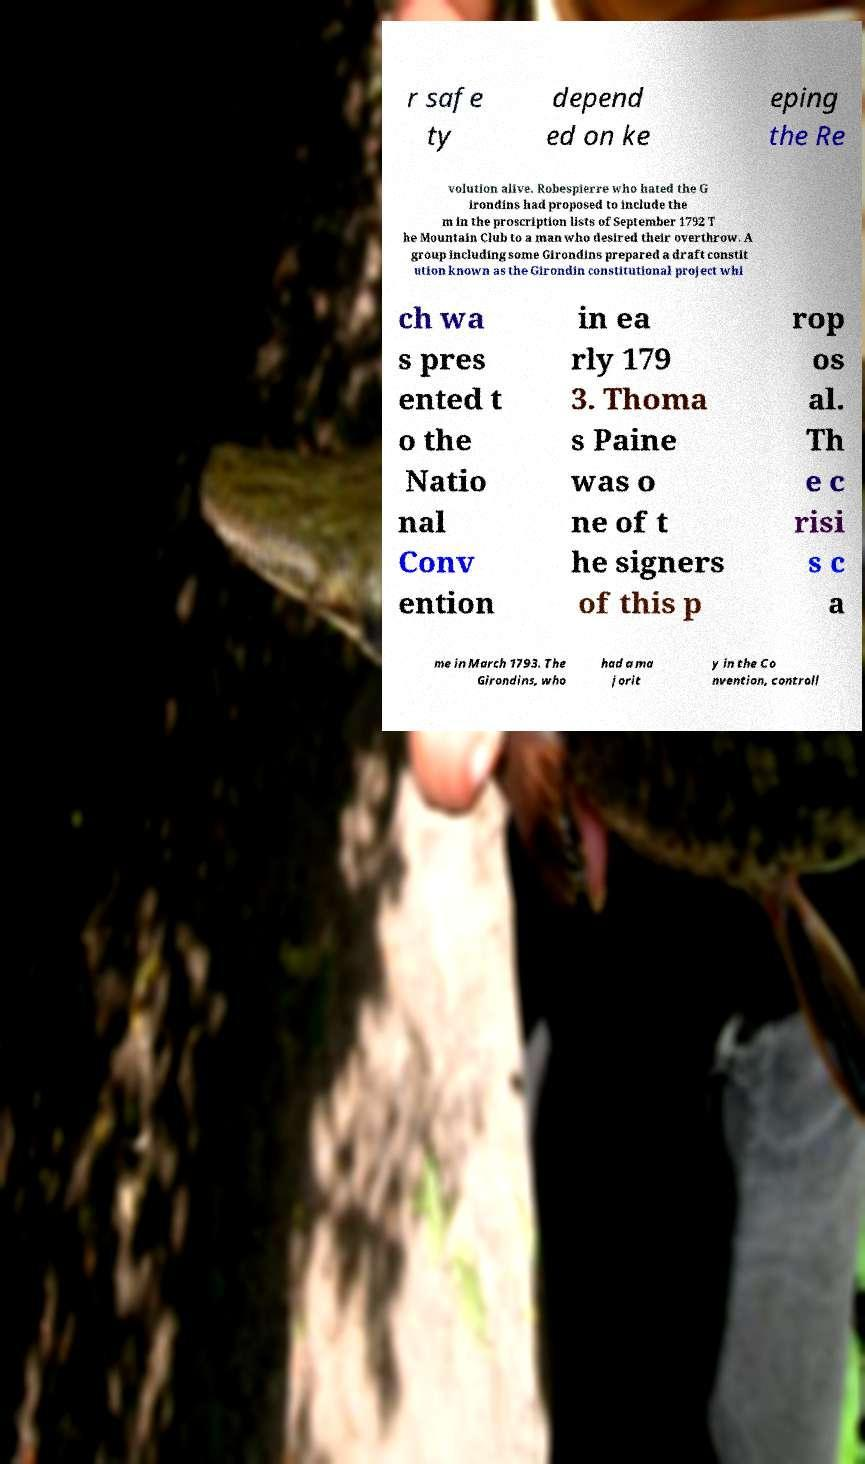Can you read and provide the text displayed in the image?This photo seems to have some interesting text. Can you extract and type it out for me? r safe ty depend ed on ke eping the Re volution alive. Robespierre who hated the G irondins had proposed to include the m in the proscription lists of September 1792 T he Mountain Club to a man who desired their overthrow. A group including some Girondins prepared a draft constit ution known as the Girondin constitutional project whi ch wa s pres ented t o the Natio nal Conv ention in ea rly 179 3. Thoma s Paine was o ne of t he signers of this p rop os al. Th e c risi s c a me in March 1793. The Girondins, who had a ma jorit y in the Co nvention, controll 